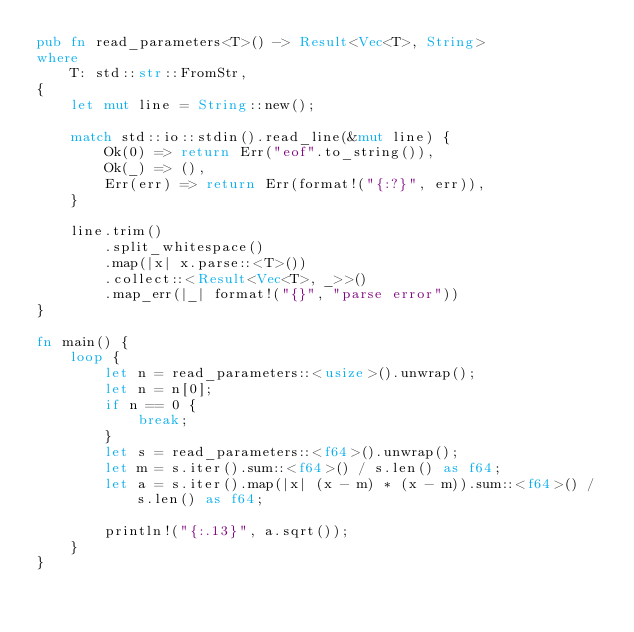Convert code to text. <code><loc_0><loc_0><loc_500><loc_500><_Rust_>pub fn read_parameters<T>() -> Result<Vec<T>, String>
where
    T: std::str::FromStr,
{
    let mut line = String::new();

    match std::io::stdin().read_line(&mut line) {
        Ok(0) => return Err("eof".to_string()),
        Ok(_) => (),
        Err(err) => return Err(format!("{:?}", err)),
    }

    line.trim()
        .split_whitespace()
        .map(|x| x.parse::<T>())
        .collect::<Result<Vec<T>, _>>()
        .map_err(|_| format!("{}", "parse error"))
}

fn main() {
    loop {
        let n = read_parameters::<usize>().unwrap();
        let n = n[0];
        if n == 0 {
            break;
        }
        let s = read_parameters::<f64>().unwrap();
        let m = s.iter().sum::<f64>() / s.len() as f64;
        let a = s.iter().map(|x| (x - m) * (x - m)).sum::<f64>() / s.len() as f64;

        println!("{:.13}", a.sqrt());
    }
}

</code> 